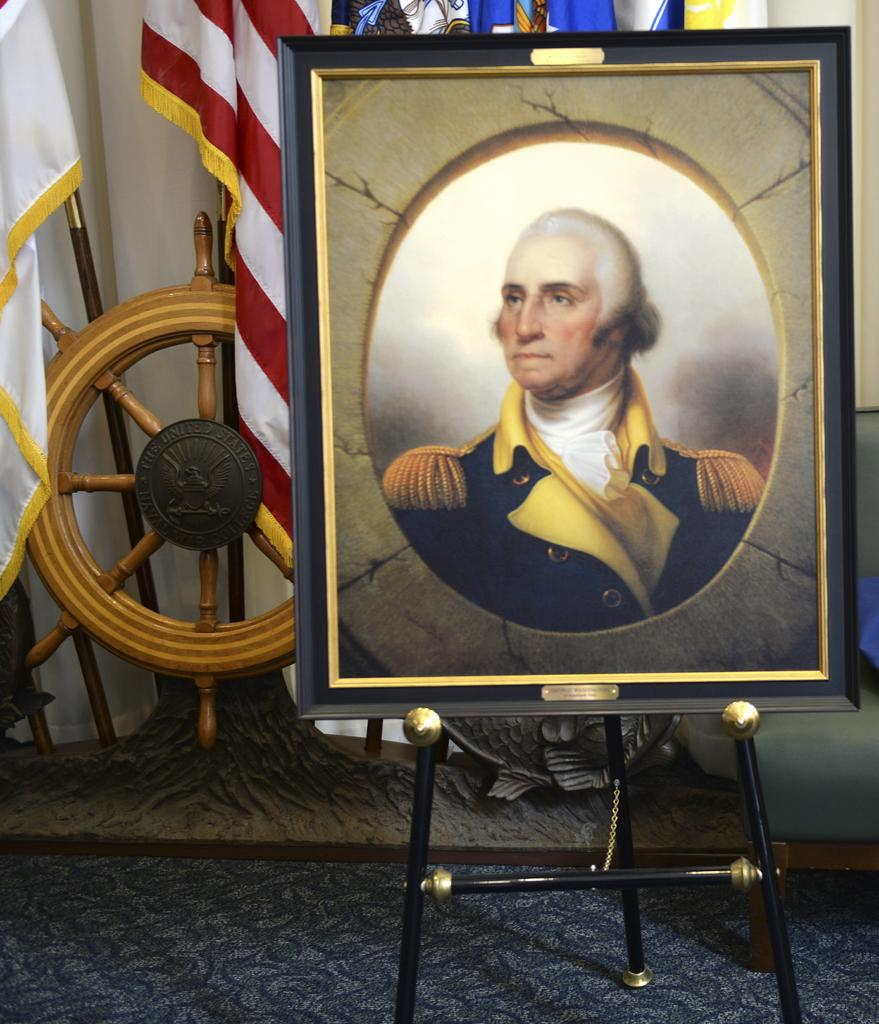What type of structure surrounds the picture in the image? The picture has a frame, which is on a stand. What is the floor covering in the image? The floor has a carpet. What can be seen on the backside of the picture? There are flags and a boat wheel visible on the backside of the picture. What is behind the picture in the image? There is a wall behind the picture. How many icicles are hanging from the boat wheel in the image? There are no icicles present in the image, as it is not a winter scene. 